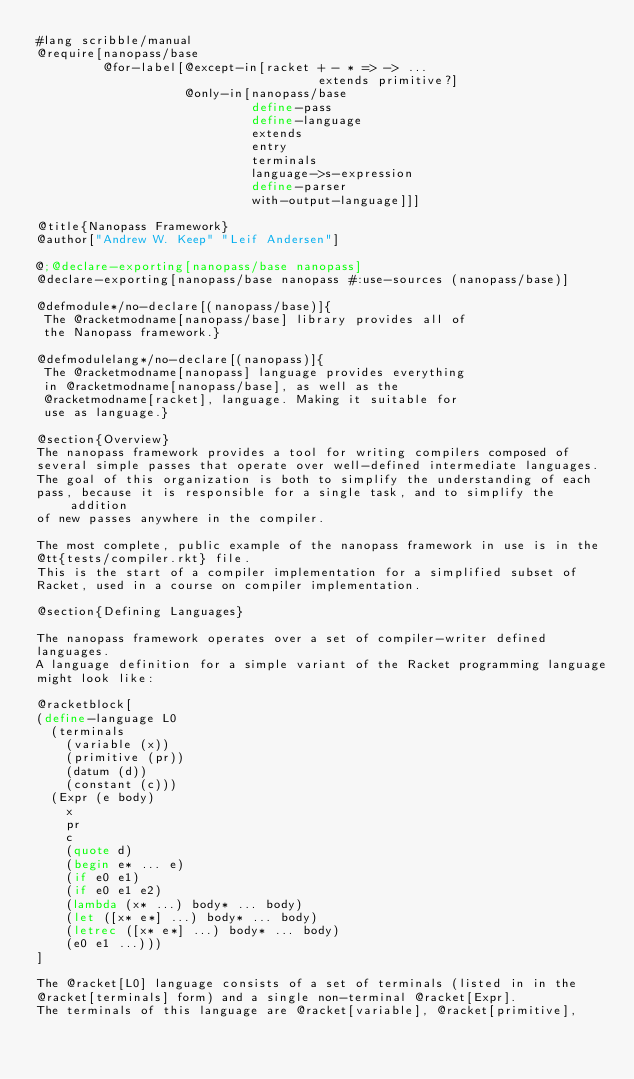Convert code to text. <code><loc_0><loc_0><loc_500><loc_500><_Racket_>#lang scribble/manual
@require[nanopass/base
         @for-label[@except-in[racket + - * => -> ...
                                      extends primitive?]
                    @only-in[nanopass/base
                             define-pass
                             define-language
                             extends
                             entry
                             terminals
                             language->s-expression
                             define-parser
                             with-output-language]]]

@title{Nanopass Framework}
@author["Andrew W. Keep" "Leif Andersen"]

@;@declare-exporting[nanopass/base nanopass]
@declare-exporting[nanopass/base nanopass #:use-sources (nanopass/base)]

@defmodule*/no-declare[(nanopass/base)]{
 The @racketmodname[nanopass/base] library provides all of
 the Nanopass framework.}

@defmodulelang*/no-declare[(nanopass)]{
 The @racketmodname[nanopass] language provides everything
 in @racketmodname[nanopass/base], as well as the 
 @racketmodname[racket], language. Making it suitable for
 use as language.}

@section{Overview}
The nanopass framework provides a tool for writing compilers composed of
several simple passes that operate over well-defined intermediate languages.
The goal of this organization is both to simplify the understanding of each
pass, because it is responsible for a single task, and to simplify the addition
of new passes anywhere in the compiler.

The most complete, public example of the nanopass framework in use is in the
@tt{tests/compiler.rkt} file.
This is the start of a compiler implementation for a simplified subset of
Racket, used in a course on compiler implementation.

@section{Defining Languages}

The nanopass framework operates over a set of compiler-writer defined
languages.
A language definition for a simple variant of the Racket programming language
might look like:

@racketblock[
(define-language L0
  (terminals
    (variable (x))
    (primitive (pr))
    (datum (d))
    (constant (c)))
  (Expr (e body)
    x
    pr
    c
    (quote d)
    (begin e* ... e)
    (if e0 e1)
    (if e0 e1 e2)
    (lambda (x* ...) body* ... body)
    (let ([x* e*] ...) body* ... body)
    (letrec ([x* e*] ...) body* ... body)
    (e0 e1 ...)))
]

The @racket[L0] language consists of a set of terminals (listed in in the
@racket[terminals] form) and a single non-terminal @racket[Expr].
The terminals of this language are @racket[variable], @racket[primitive],</code> 